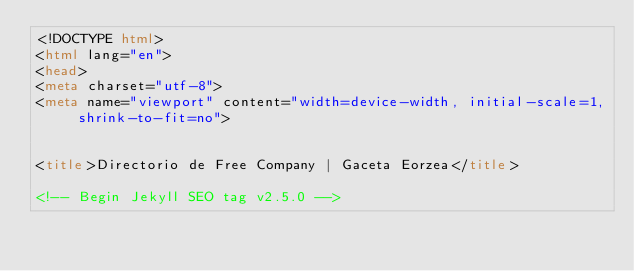Convert code to text. <code><loc_0><loc_0><loc_500><loc_500><_HTML_><!DOCTYPE html>
<html lang="en">
<head>
<meta charset="utf-8">
<meta name="viewport" content="width=device-width, initial-scale=1, shrink-to-fit=no">


<title>Directorio de Free Company | Gaceta Eorzea</title>

<!-- Begin Jekyll SEO tag v2.5.0 --></code> 